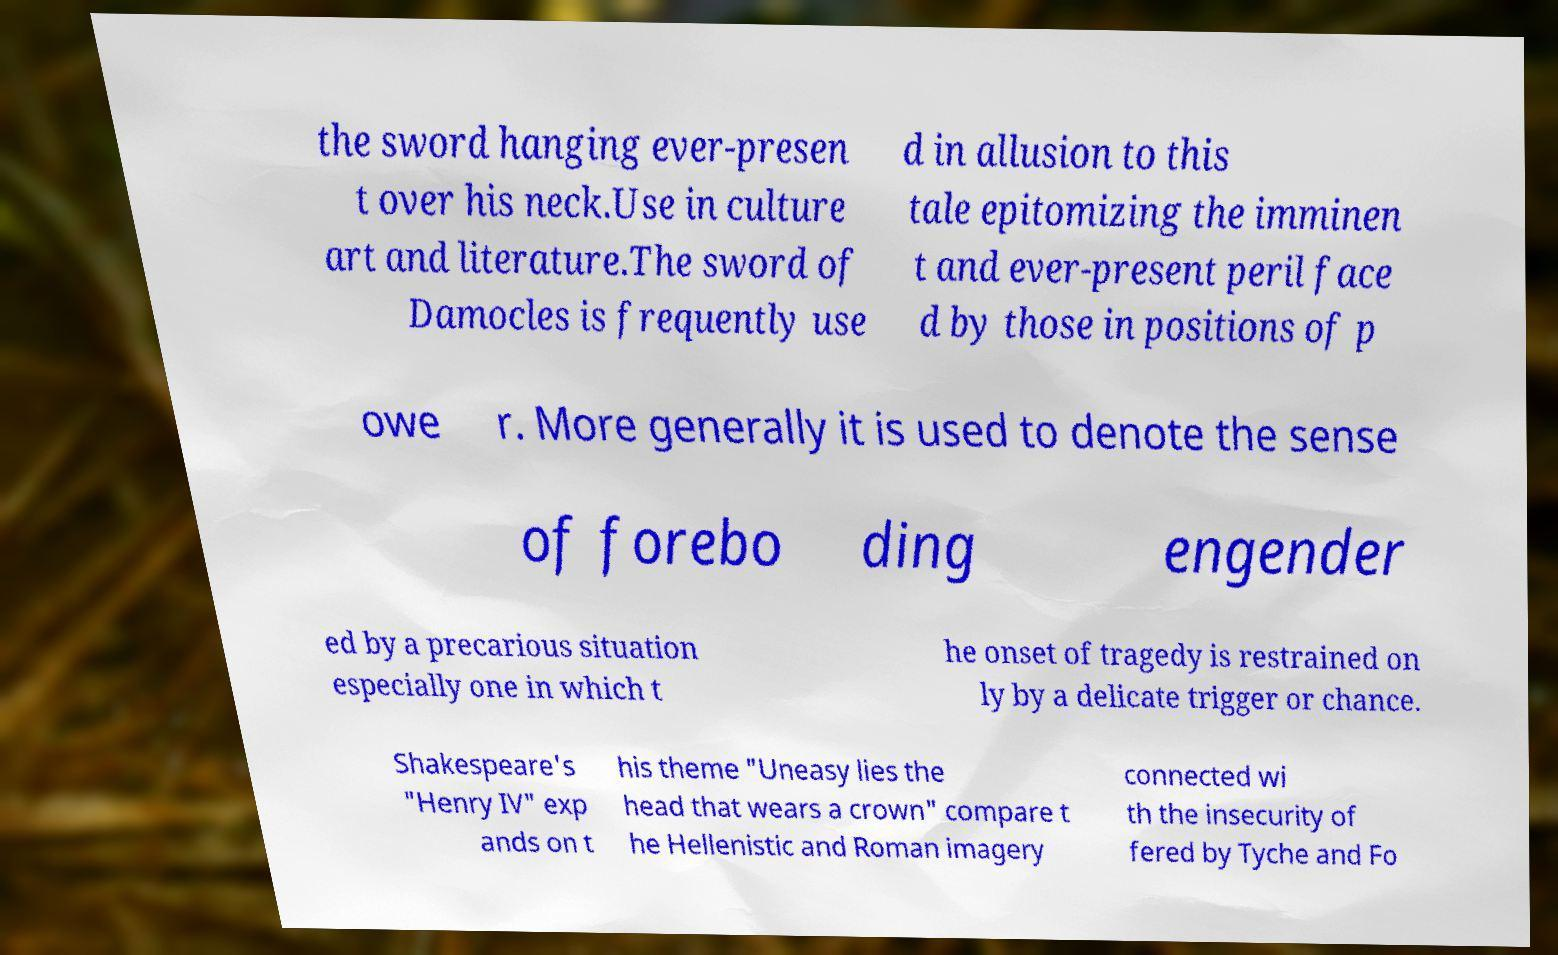Please identify and transcribe the text found in this image. the sword hanging ever-presen t over his neck.Use in culture art and literature.The sword of Damocles is frequently use d in allusion to this tale epitomizing the imminen t and ever-present peril face d by those in positions of p owe r. More generally it is used to denote the sense of forebo ding engender ed by a precarious situation especially one in which t he onset of tragedy is restrained on ly by a delicate trigger or chance. Shakespeare's "Henry IV" exp ands on t his theme "Uneasy lies the head that wears a crown" compare t he Hellenistic and Roman imagery connected wi th the insecurity of fered by Tyche and Fo 